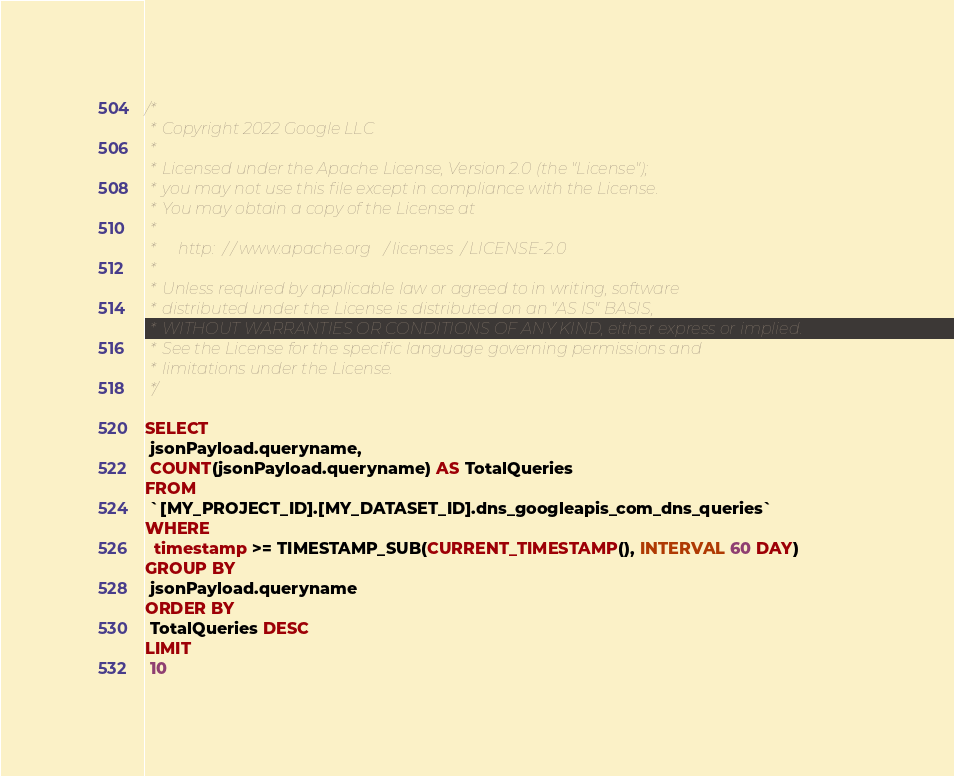Convert code to text. <code><loc_0><loc_0><loc_500><loc_500><_SQL_>/*
 * Copyright 2022 Google LLC
 *
 * Licensed under the Apache License, Version 2.0 (the "License");
 * you may not use this file except in compliance with the License.
 * You may obtain a copy of the License at
 *
 *     http://www.apache.org/licenses/LICENSE-2.0
 *
 * Unless required by applicable law or agreed to in writing, software
 * distributed under the License is distributed on an "AS IS" BASIS,
 * WITHOUT WARRANTIES OR CONDITIONS OF ANY KIND, either express or implied.
 * See the License for the specific language governing permissions and
 * limitations under the License.
 */

SELECT
 jsonPayload.queryname,
 COUNT(jsonPayload.queryname) AS TotalQueries
FROM
 `[MY_PROJECT_ID].[MY_DATASET_ID].dns_googleapis_com_dns_queries`
WHERE
  timestamp >= TIMESTAMP_SUB(CURRENT_TIMESTAMP(), INTERVAL 60 DAY)
GROUP BY
 jsonPayload.queryname
ORDER BY
 TotalQueries DESC
LIMIT
 10</code> 